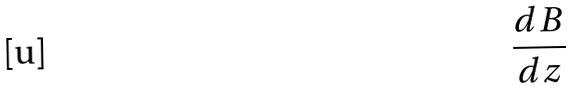<formula> <loc_0><loc_0><loc_500><loc_500>\frac { d B } { d z }</formula> 